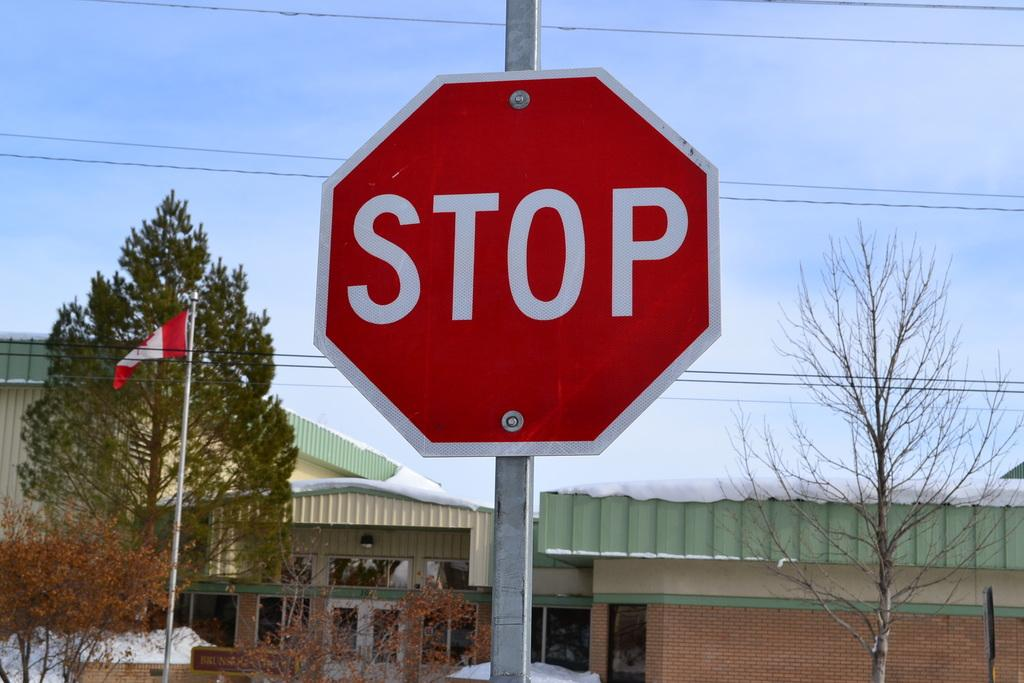Provide a one-sentence caption for the provided image. A stop sign against a bright blue sky in Canada. 